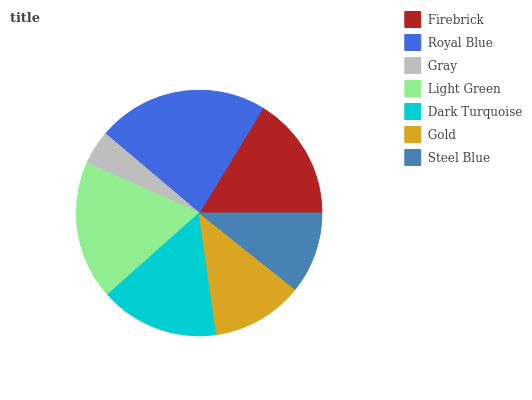Is Gray the minimum?
Answer yes or no. Yes. Is Royal Blue the maximum?
Answer yes or no. Yes. Is Royal Blue the minimum?
Answer yes or no. No. Is Gray the maximum?
Answer yes or no. No. Is Royal Blue greater than Gray?
Answer yes or no. Yes. Is Gray less than Royal Blue?
Answer yes or no. Yes. Is Gray greater than Royal Blue?
Answer yes or no. No. Is Royal Blue less than Gray?
Answer yes or no. No. Is Dark Turquoise the high median?
Answer yes or no. Yes. Is Dark Turquoise the low median?
Answer yes or no. Yes. Is Royal Blue the high median?
Answer yes or no. No. Is Steel Blue the low median?
Answer yes or no. No. 